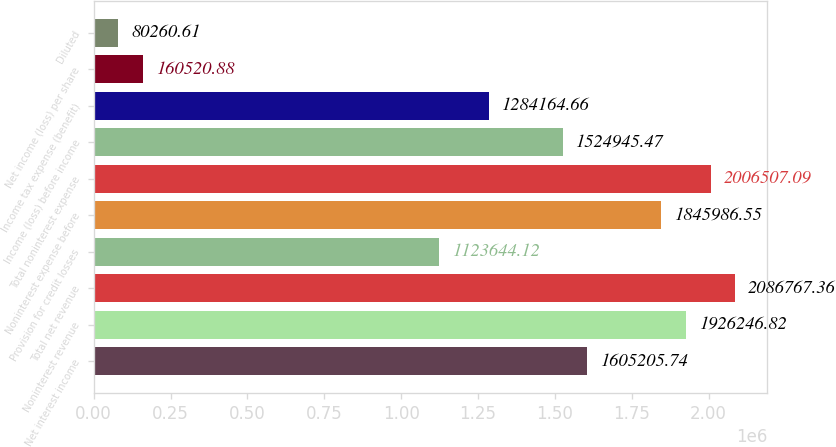Convert chart. <chart><loc_0><loc_0><loc_500><loc_500><bar_chart><fcel>Net interest income<fcel>Noninterest revenue<fcel>Total net revenue<fcel>Provision for credit losses<fcel>Noninterest expense before<fcel>Total noninterest expense<fcel>Income (loss) before income<fcel>Income tax expense (benefit)<fcel>Net income (loss) per share<fcel>Diluted<nl><fcel>1.60521e+06<fcel>1.92625e+06<fcel>2.08677e+06<fcel>1.12364e+06<fcel>1.84599e+06<fcel>2.00651e+06<fcel>1.52495e+06<fcel>1.28416e+06<fcel>160521<fcel>80260.6<nl></chart> 